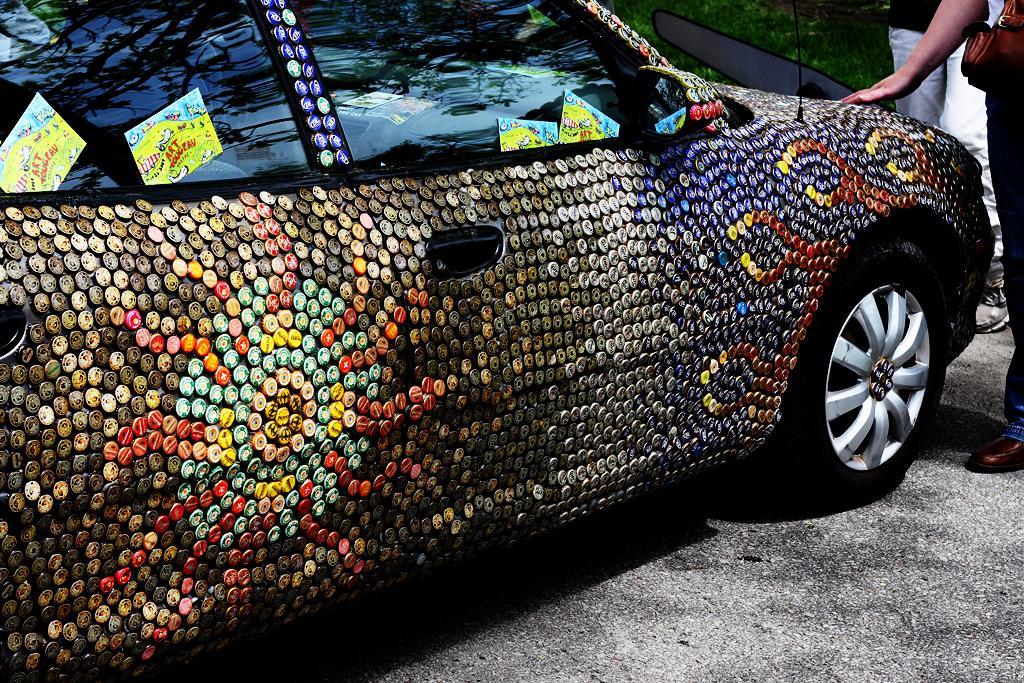Could you give a brief overview of what you see in this image? In the image we can see there is a car parked on the road and there are badges pasted on the car. There is a woman standing near the car. 